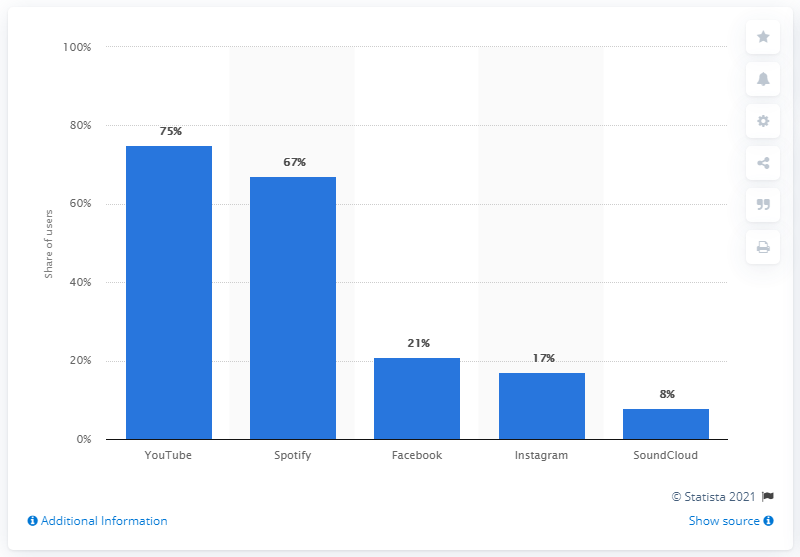Indicate a few pertinent items in this graphic. According to data from 2020, YouTube was the most popular digital music service in Sweden. 